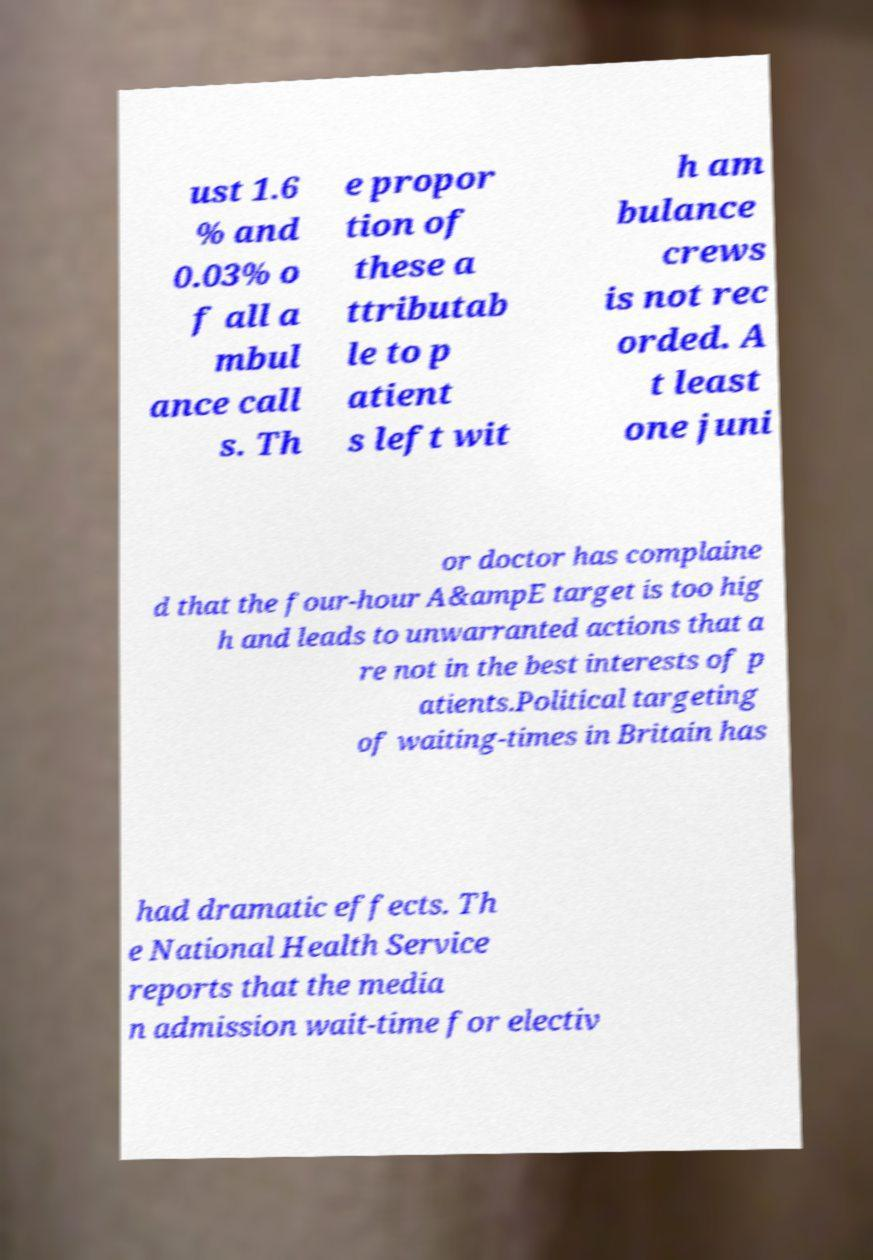Can you accurately transcribe the text from the provided image for me? ust 1.6 % and 0.03% o f all a mbul ance call s. Th e propor tion of these a ttributab le to p atient s left wit h am bulance crews is not rec orded. A t least one juni or doctor has complaine d that the four-hour A&ampE target is too hig h and leads to unwarranted actions that a re not in the best interests of p atients.Political targeting of waiting-times in Britain has had dramatic effects. Th e National Health Service reports that the media n admission wait-time for electiv 